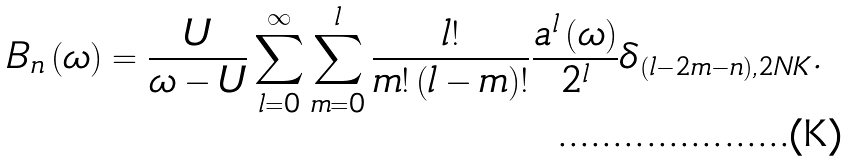Convert formula to latex. <formula><loc_0><loc_0><loc_500><loc_500>B _ { n } \left ( \omega \right ) = \frac { U } { \omega - U } \sum _ { l = 0 } ^ { \infty } \sum _ { m = 0 } ^ { l } \frac { l ! } { m ! \left ( l - m \right ) ! } \frac { a ^ { l } \left ( \omega \right ) } { 2 ^ { l } } \delta _ { \left ( l - 2 m - n \right ) , 2 N K } .</formula> 